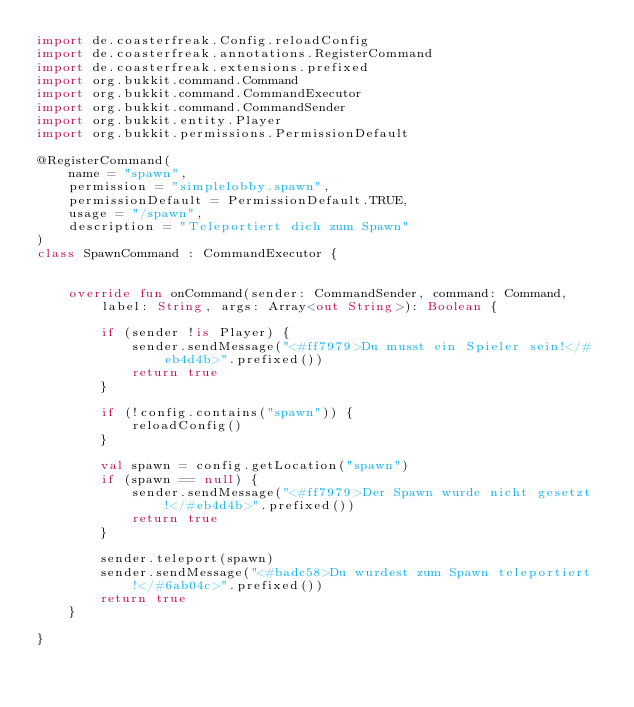Convert code to text. <code><loc_0><loc_0><loc_500><loc_500><_Kotlin_>import de.coasterfreak.Config.reloadConfig
import de.coasterfreak.annotations.RegisterCommand
import de.coasterfreak.extensions.prefixed
import org.bukkit.command.Command
import org.bukkit.command.CommandExecutor
import org.bukkit.command.CommandSender
import org.bukkit.entity.Player
import org.bukkit.permissions.PermissionDefault

@RegisterCommand(
    name = "spawn",
    permission = "simplelobby.spawn",
    permissionDefault = PermissionDefault.TRUE,
    usage = "/spawn",
    description = "Teleportiert dich zum Spawn"
)
class SpawnCommand : CommandExecutor {


    override fun onCommand(sender: CommandSender, command: Command, label: String, args: Array<out String>): Boolean {

        if (sender !is Player) {
            sender.sendMessage("<#ff7979>Du musst ein Spieler sein!</#eb4d4b>".prefixed())
            return true
        }

        if (!config.contains("spawn")) {
            reloadConfig()
        }

        val spawn = config.getLocation("spawn")
        if (spawn == null) {
            sender.sendMessage("<#ff7979>Der Spawn wurde nicht gesetzt!</#eb4d4b>".prefixed())
            return true
        }

        sender.teleport(spawn)
        sender.sendMessage("<#badc58>Du wurdest zum Spawn teleportiert!</#6ab04c>".prefixed())
        return true
    }

}</code> 